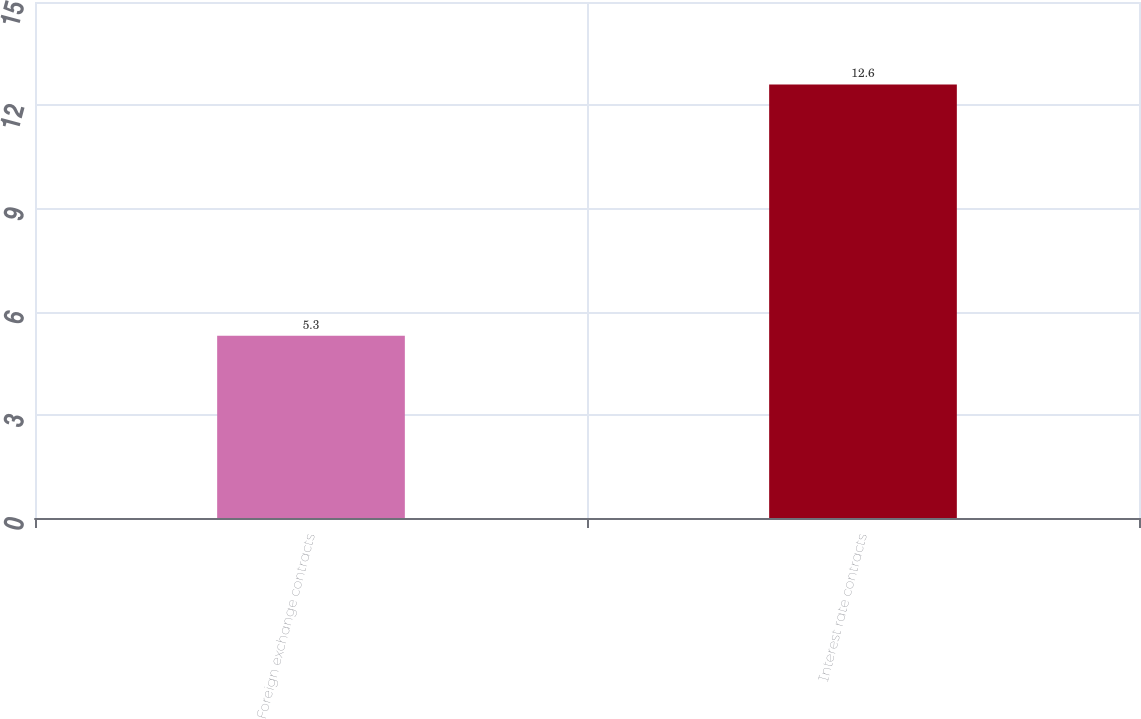Convert chart. <chart><loc_0><loc_0><loc_500><loc_500><bar_chart><fcel>Foreign exchange contracts<fcel>Interest rate contracts<nl><fcel>5.3<fcel>12.6<nl></chart> 